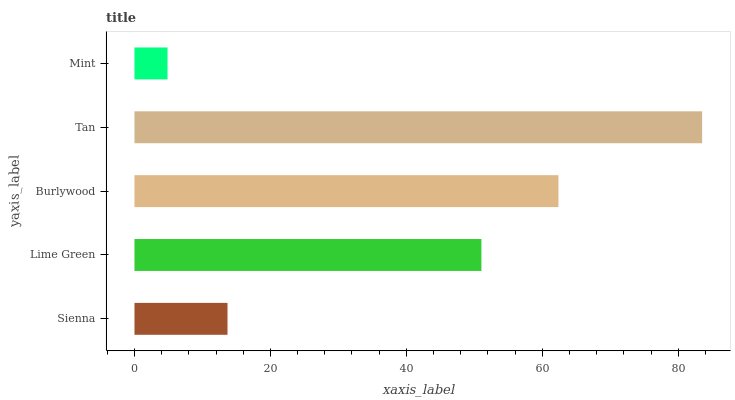Is Mint the minimum?
Answer yes or no. Yes. Is Tan the maximum?
Answer yes or no. Yes. Is Lime Green the minimum?
Answer yes or no. No. Is Lime Green the maximum?
Answer yes or no. No. Is Lime Green greater than Sienna?
Answer yes or no. Yes. Is Sienna less than Lime Green?
Answer yes or no. Yes. Is Sienna greater than Lime Green?
Answer yes or no. No. Is Lime Green less than Sienna?
Answer yes or no. No. Is Lime Green the high median?
Answer yes or no. Yes. Is Lime Green the low median?
Answer yes or no. Yes. Is Burlywood the high median?
Answer yes or no. No. Is Tan the low median?
Answer yes or no. No. 